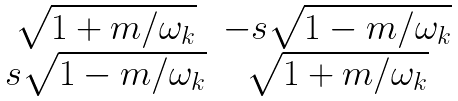<formula> <loc_0><loc_0><loc_500><loc_500>\begin{matrix} \sqrt { 1 + m / \omega _ { k } } & - s \sqrt { 1 - m / \omega _ { k } } \\ s \sqrt { 1 - m / \omega _ { k } } & \sqrt { 1 + m / \omega _ { k } } \end{matrix}</formula> 